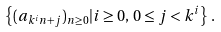<formula> <loc_0><loc_0><loc_500><loc_500>\left \{ ( a _ { k ^ { i } n + j } ) _ { n \geq 0 } | i \geq 0 , \, 0 \leq j < k ^ { i } \right \} \, .</formula> 